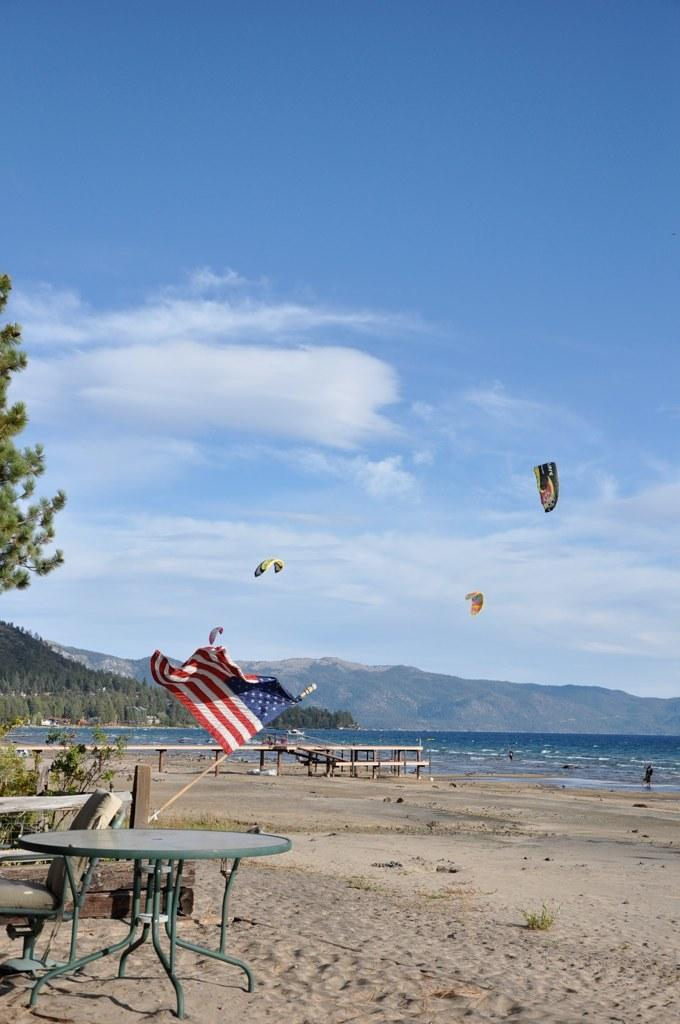What can be seen at the top of the image? The sky is visible in the image. What is located in the middle of the image? There is a flag in the middle of the image. What furniture is present on the left side of the image? There is a table and a chair in the left side of the image. Can you see the ocean in the image? No, there is no ocean present in the image. Is there a yoke visible in the image? No, there is no yoke present in the image. 